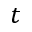<formula> <loc_0><loc_0><loc_500><loc_500>t</formula> 